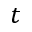<formula> <loc_0><loc_0><loc_500><loc_500>t</formula> 